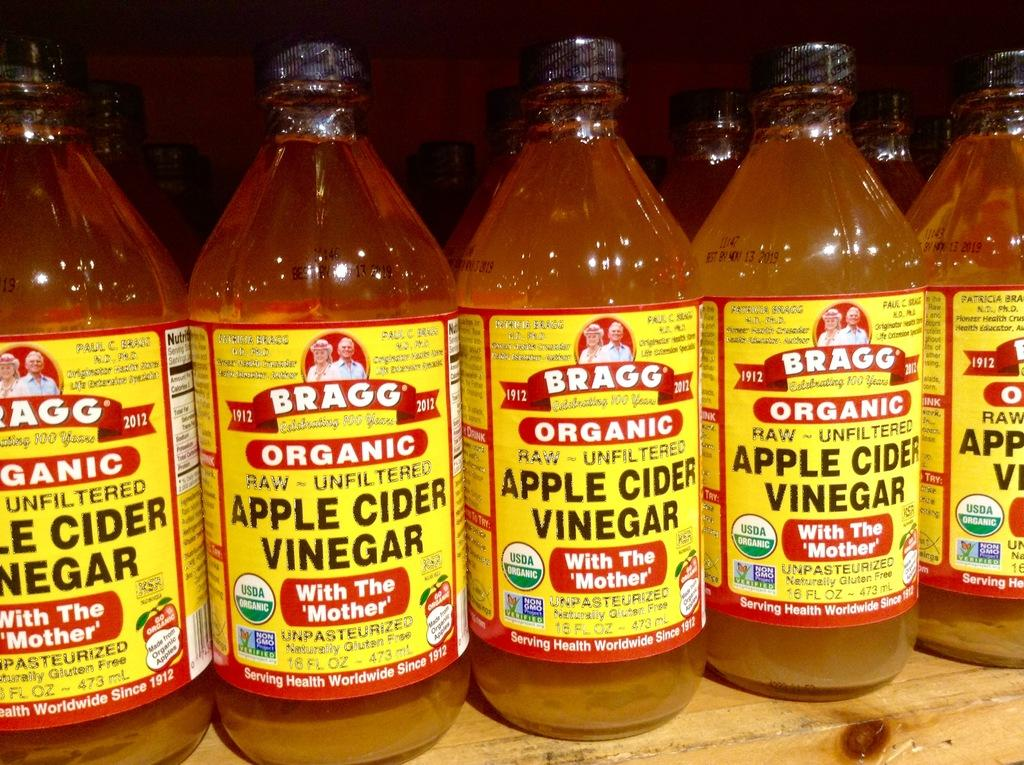<image>
Write a terse but informative summary of the picture. Several containers of Apple Cider Vinegar with yellow labels lined up on a shelf. 